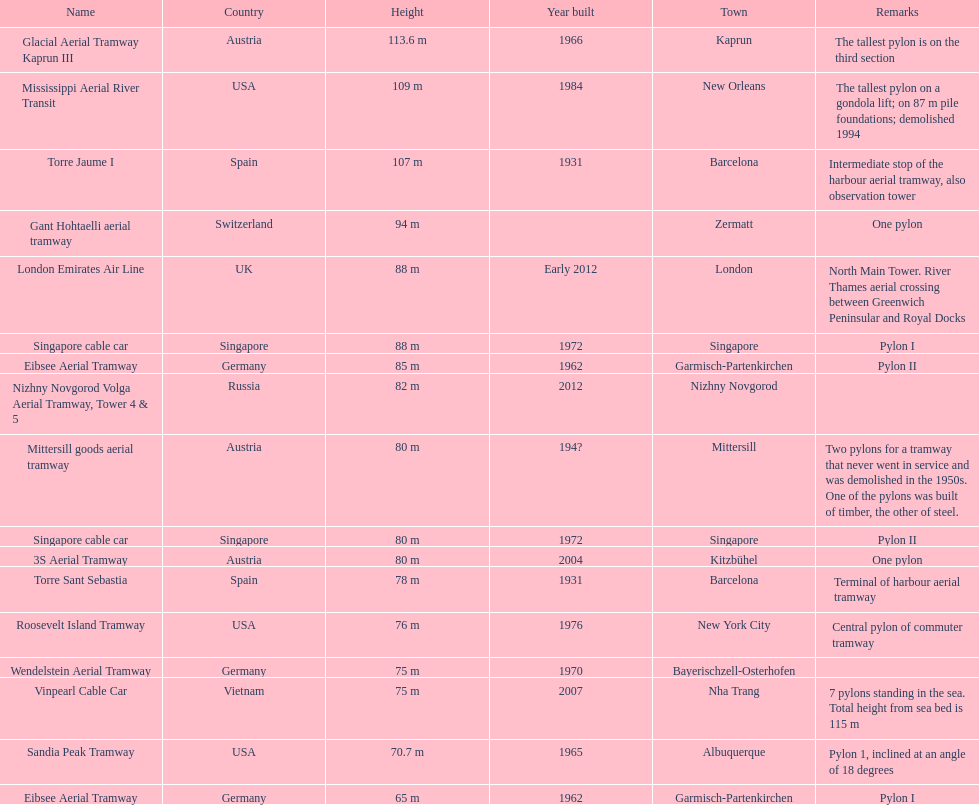What is the total number of tallest pylons in austria? 3. 